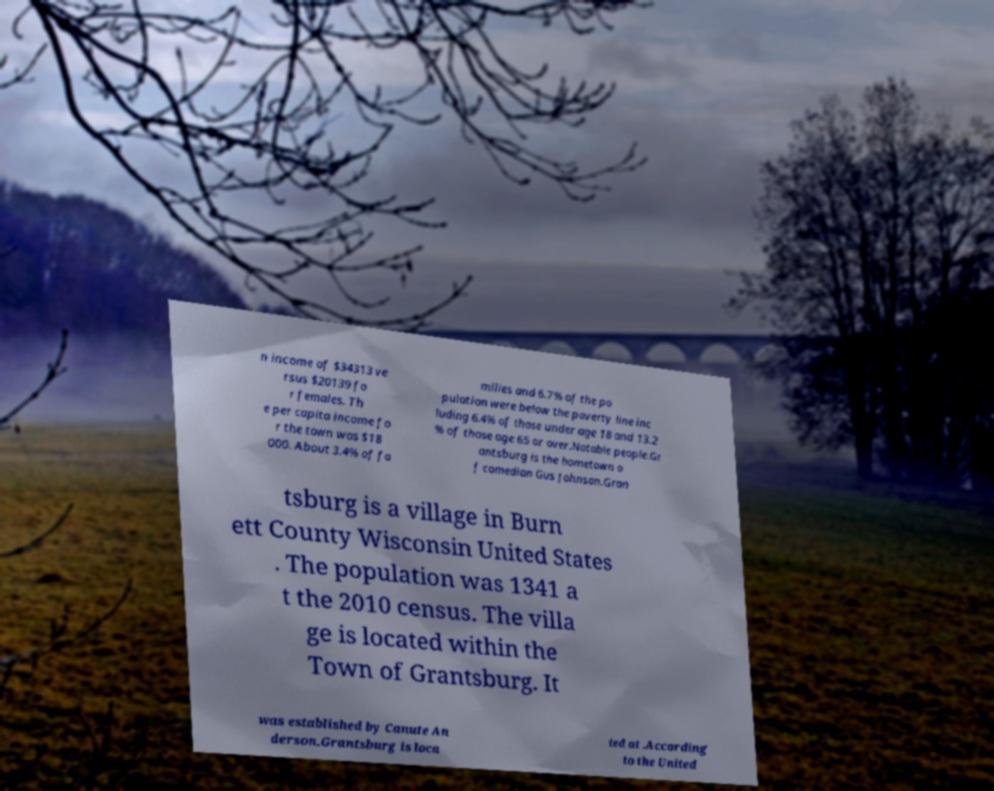Could you assist in decoding the text presented in this image and type it out clearly? n income of $34313 ve rsus $20139 fo r females. Th e per capita income fo r the town was $18 000. About 3.4% of fa milies and 6.7% of the po pulation were below the poverty line inc luding 6.4% of those under age 18 and 13.2 % of those age 65 or over.Notable people.Gr antsburg is the hometown o f comedian Gus Johnson.Gran tsburg is a village in Burn ett County Wisconsin United States . The population was 1341 a t the 2010 census. The villa ge is located within the Town of Grantsburg. It was established by Canute An derson.Grantsburg is loca ted at .According to the United 